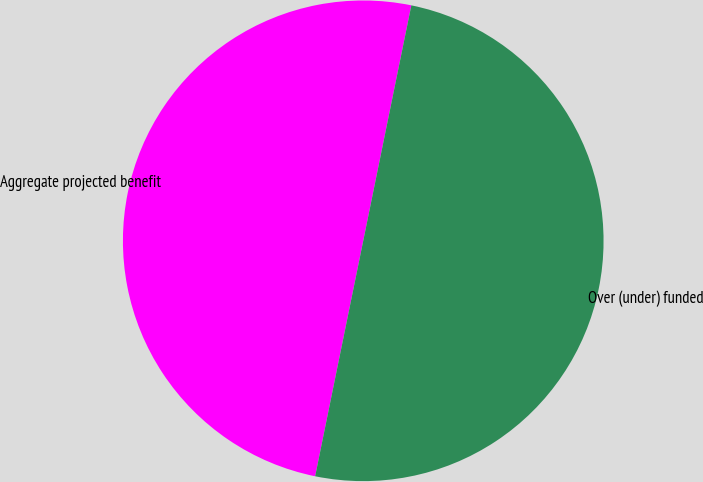Convert chart to OTSL. <chart><loc_0><loc_0><loc_500><loc_500><pie_chart><fcel>Aggregate projected benefit<fcel>Over (under) funded<nl><fcel>50.0%<fcel>50.0%<nl></chart> 